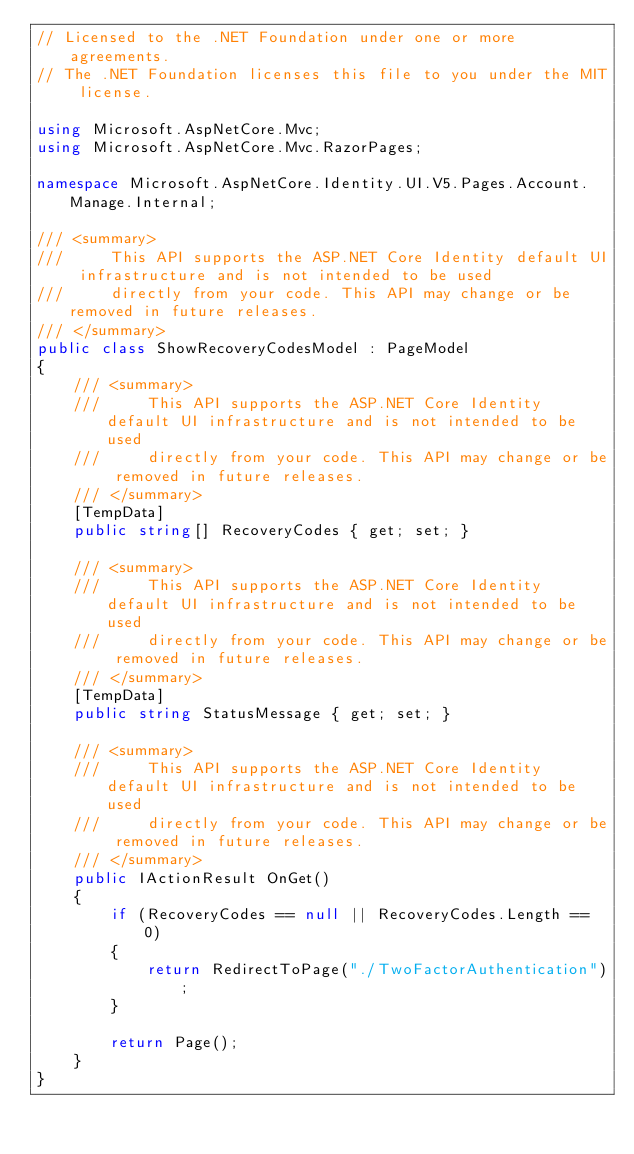<code> <loc_0><loc_0><loc_500><loc_500><_C#_>// Licensed to the .NET Foundation under one or more agreements.
// The .NET Foundation licenses this file to you under the MIT license.

using Microsoft.AspNetCore.Mvc;
using Microsoft.AspNetCore.Mvc.RazorPages;

namespace Microsoft.AspNetCore.Identity.UI.V5.Pages.Account.Manage.Internal;

/// <summary>
///     This API supports the ASP.NET Core Identity default UI infrastructure and is not intended to be used
///     directly from your code. This API may change or be removed in future releases.
/// </summary>
public class ShowRecoveryCodesModel : PageModel
{
    /// <summary>
    ///     This API supports the ASP.NET Core Identity default UI infrastructure and is not intended to be used
    ///     directly from your code. This API may change or be removed in future releases.
    /// </summary>
    [TempData]
    public string[] RecoveryCodes { get; set; }

    /// <summary>
    ///     This API supports the ASP.NET Core Identity default UI infrastructure and is not intended to be used
    ///     directly from your code. This API may change or be removed in future releases.
    /// </summary>
    [TempData]
    public string StatusMessage { get; set; }

    /// <summary>
    ///     This API supports the ASP.NET Core Identity default UI infrastructure and is not intended to be used
    ///     directly from your code. This API may change or be removed in future releases.
    /// </summary>
    public IActionResult OnGet()
    {
        if (RecoveryCodes == null || RecoveryCodes.Length == 0)
        {
            return RedirectToPage("./TwoFactorAuthentication");
        }

        return Page();
    }
}
</code> 